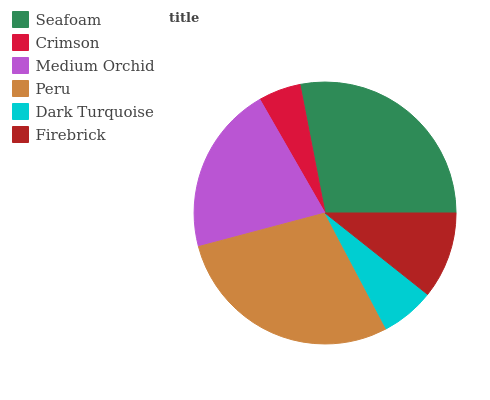Is Crimson the minimum?
Answer yes or no. Yes. Is Peru the maximum?
Answer yes or no. Yes. Is Medium Orchid the minimum?
Answer yes or no. No. Is Medium Orchid the maximum?
Answer yes or no. No. Is Medium Orchid greater than Crimson?
Answer yes or no. Yes. Is Crimson less than Medium Orchid?
Answer yes or no. Yes. Is Crimson greater than Medium Orchid?
Answer yes or no. No. Is Medium Orchid less than Crimson?
Answer yes or no. No. Is Medium Orchid the high median?
Answer yes or no. Yes. Is Firebrick the low median?
Answer yes or no. Yes. Is Dark Turquoise the high median?
Answer yes or no. No. Is Peru the low median?
Answer yes or no. No. 